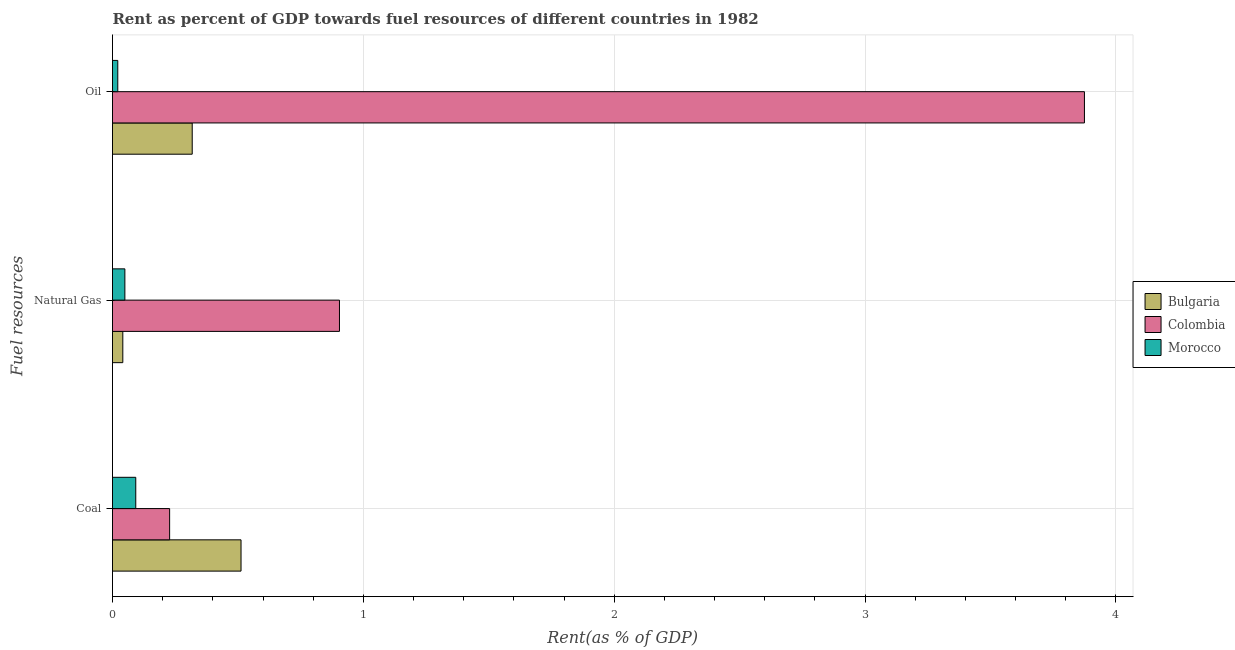Are the number of bars per tick equal to the number of legend labels?
Keep it short and to the point. Yes. How many bars are there on the 1st tick from the top?
Offer a very short reply. 3. How many bars are there on the 3rd tick from the bottom?
Your answer should be very brief. 3. What is the label of the 1st group of bars from the top?
Your answer should be compact. Oil. What is the rent towards natural gas in Bulgaria?
Keep it short and to the point. 0.04. Across all countries, what is the maximum rent towards natural gas?
Keep it short and to the point. 0.9. Across all countries, what is the minimum rent towards natural gas?
Offer a very short reply. 0.04. In which country was the rent towards oil minimum?
Keep it short and to the point. Morocco. What is the total rent towards oil in the graph?
Give a very brief answer. 4.21. What is the difference between the rent towards oil in Colombia and that in Morocco?
Your answer should be compact. 3.85. What is the difference between the rent towards natural gas in Morocco and the rent towards oil in Bulgaria?
Provide a short and direct response. -0.27. What is the average rent towards coal per country?
Give a very brief answer. 0.28. What is the difference between the rent towards coal and rent towards oil in Colombia?
Provide a succinct answer. -3.65. In how many countries, is the rent towards oil greater than 2.2 %?
Your answer should be very brief. 1. What is the ratio of the rent towards natural gas in Morocco to that in Colombia?
Make the answer very short. 0.05. Is the rent towards coal in Morocco less than that in Colombia?
Make the answer very short. Yes. What is the difference between the highest and the second highest rent towards coal?
Your response must be concise. 0.28. What is the difference between the highest and the lowest rent towards natural gas?
Your answer should be compact. 0.86. Is the sum of the rent towards natural gas in Colombia and Morocco greater than the maximum rent towards oil across all countries?
Give a very brief answer. No. How many bars are there?
Provide a succinct answer. 9. Are all the bars in the graph horizontal?
Make the answer very short. Yes. How many countries are there in the graph?
Provide a short and direct response. 3. What is the difference between two consecutive major ticks on the X-axis?
Offer a terse response. 1. Are the values on the major ticks of X-axis written in scientific E-notation?
Offer a very short reply. No. Does the graph contain grids?
Make the answer very short. Yes. Where does the legend appear in the graph?
Your response must be concise. Center right. How many legend labels are there?
Provide a succinct answer. 3. What is the title of the graph?
Your answer should be very brief. Rent as percent of GDP towards fuel resources of different countries in 1982. What is the label or title of the X-axis?
Your answer should be very brief. Rent(as % of GDP). What is the label or title of the Y-axis?
Your response must be concise. Fuel resources. What is the Rent(as % of GDP) of Bulgaria in Coal?
Give a very brief answer. 0.51. What is the Rent(as % of GDP) in Colombia in Coal?
Provide a short and direct response. 0.23. What is the Rent(as % of GDP) of Morocco in Coal?
Ensure brevity in your answer.  0.09. What is the Rent(as % of GDP) of Bulgaria in Natural Gas?
Offer a very short reply. 0.04. What is the Rent(as % of GDP) of Colombia in Natural Gas?
Offer a terse response. 0.9. What is the Rent(as % of GDP) in Morocco in Natural Gas?
Your response must be concise. 0.05. What is the Rent(as % of GDP) of Bulgaria in Oil?
Your answer should be compact. 0.32. What is the Rent(as % of GDP) in Colombia in Oil?
Offer a very short reply. 3.87. What is the Rent(as % of GDP) of Morocco in Oil?
Give a very brief answer. 0.02. Across all Fuel resources, what is the maximum Rent(as % of GDP) of Bulgaria?
Your response must be concise. 0.51. Across all Fuel resources, what is the maximum Rent(as % of GDP) in Colombia?
Your answer should be compact. 3.87. Across all Fuel resources, what is the maximum Rent(as % of GDP) in Morocco?
Keep it short and to the point. 0.09. Across all Fuel resources, what is the minimum Rent(as % of GDP) in Bulgaria?
Your response must be concise. 0.04. Across all Fuel resources, what is the minimum Rent(as % of GDP) in Colombia?
Offer a terse response. 0.23. Across all Fuel resources, what is the minimum Rent(as % of GDP) of Morocco?
Your answer should be compact. 0.02. What is the total Rent(as % of GDP) of Bulgaria in the graph?
Your answer should be compact. 0.87. What is the total Rent(as % of GDP) in Colombia in the graph?
Your response must be concise. 5.01. What is the total Rent(as % of GDP) of Morocco in the graph?
Your answer should be very brief. 0.16. What is the difference between the Rent(as % of GDP) in Bulgaria in Coal and that in Natural Gas?
Make the answer very short. 0.47. What is the difference between the Rent(as % of GDP) in Colombia in Coal and that in Natural Gas?
Ensure brevity in your answer.  -0.68. What is the difference between the Rent(as % of GDP) of Morocco in Coal and that in Natural Gas?
Make the answer very short. 0.04. What is the difference between the Rent(as % of GDP) in Bulgaria in Coal and that in Oil?
Ensure brevity in your answer.  0.19. What is the difference between the Rent(as % of GDP) in Colombia in Coal and that in Oil?
Your response must be concise. -3.65. What is the difference between the Rent(as % of GDP) of Morocco in Coal and that in Oil?
Offer a very short reply. 0.07. What is the difference between the Rent(as % of GDP) in Bulgaria in Natural Gas and that in Oil?
Offer a very short reply. -0.28. What is the difference between the Rent(as % of GDP) of Colombia in Natural Gas and that in Oil?
Offer a very short reply. -2.97. What is the difference between the Rent(as % of GDP) of Morocco in Natural Gas and that in Oil?
Offer a terse response. 0.03. What is the difference between the Rent(as % of GDP) of Bulgaria in Coal and the Rent(as % of GDP) of Colombia in Natural Gas?
Your answer should be compact. -0.39. What is the difference between the Rent(as % of GDP) in Bulgaria in Coal and the Rent(as % of GDP) in Morocco in Natural Gas?
Your answer should be very brief. 0.46. What is the difference between the Rent(as % of GDP) of Colombia in Coal and the Rent(as % of GDP) of Morocco in Natural Gas?
Offer a terse response. 0.18. What is the difference between the Rent(as % of GDP) in Bulgaria in Coal and the Rent(as % of GDP) in Colombia in Oil?
Keep it short and to the point. -3.36. What is the difference between the Rent(as % of GDP) in Bulgaria in Coal and the Rent(as % of GDP) in Morocco in Oil?
Give a very brief answer. 0.49. What is the difference between the Rent(as % of GDP) in Colombia in Coal and the Rent(as % of GDP) in Morocco in Oil?
Your response must be concise. 0.21. What is the difference between the Rent(as % of GDP) in Bulgaria in Natural Gas and the Rent(as % of GDP) in Colombia in Oil?
Your answer should be compact. -3.83. What is the difference between the Rent(as % of GDP) of Colombia in Natural Gas and the Rent(as % of GDP) of Morocco in Oil?
Offer a very short reply. 0.88. What is the average Rent(as % of GDP) in Bulgaria per Fuel resources?
Give a very brief answer. 0.29. What is the average Rent(as % of GDP) of Colombia per Fuel resources?
Provide a short and direct response. 1.67. What is the average Rent(as % of GDP) in Morocco per Fuel resources?
Make the answer very short. 0.05. What is the difference between the Rent(as % of GDP) in Bulgaria and Rent(as % of GDP) in Colombia in Coal?
Keep it short and to the point. 0.28. What is the difference between the Rent(as % of GDP) in Bulgaria and Rent(as % of GDP) in Morocco in Coal?
Provide a short and direct response. 0.42. What is the difference between the Rent(as % of GDP) in Colombia and Rent(as % of GDP) in Morocco in Coal?
Provide a succinct answer. 0.14. What is the difference between the Rent(as % of GDP) of Bulgaria and Rent(as % of GDP) of Colombia in Natural Gas?
Your response must be concise. -0.86. What is the difference between the Rent(as % of GDP) in Bulgaria and Rent(as % of GDP) in Morocco in Natural Gas?
Ensure brevity in your answer.  -0.01. What is the difference between the Rent(as % of GDP) of Colombia and Rent(as % of GDP) of Morocco in Natural Gas?
Provide a succinct answer. 0.86. What is the difference between the Rent(as % of GDP) in Bulgaria and Rent(as % of GDP) in Colombia in Oil?
Ensure brevity in your answer.  -3.56. What is the difference between the Rent(as % of GDP) of Bulgaria and Rent(as % of GDP) of Morocco in Oil?
Offer a terse response. 0.3. What is the difference between the Rent(as % of GDP) in Colombia and Rent(as % of GDP) in Morocco in Oil?
Your answer should be compact. 3.85. What is the ratio of the Rent(as % of GDP) of Bulgaria in Coal to that in Natural Gas?
Make the answer very short. 12.48. What is the ratio of the Rent(as % of GDP) of Colombia in Coal to that in Natural Gas?
Provide a succinct answer. 0.25. What is the ratio of the Rent(as % of GDP) in Morocco in Coal to that in Natural Gas?
Your answer should be compact. 1.88. What is the ratio of the Rent(as % of GDP) of Bulgaria in Coal to that in Oil?
Keep it short and to the point. 1.61. What is the ratio of the Rent(as % of GDP) in Colombia in Coal to that in Oil?
Provide a short and direct response. 0.06. What is the ratio of the Rent(as % of GDP) in Morocco in Coal to that in Oil?
Provide a succinct answer. 4.41. What is the ratio of the Rent(as % of GDP) of Bulgaria in Natural Gas to that in Oil?
Your response must be concise. 0.13. What is the ratio of the Rent(as % of GDP) in Colombia in Natural Gas to that in Oil?
Make the answer very short. 0.23. What is the ratio of the Rent(as % of GDP) of Morocco in Natural Gas to that in Oil?
Ensure brevity in your answer.  2.34. What is the difference between the highest and the second highest Rent(as % of GDP) in Bulgaria?
Provide a succinct answer. 0.19. What is the difference between the highest and the second highest Rent(as % of GDP) of Colombia?
Your answer should be very brief. 2.97. What is the difference between the highest and the second highest Rent(as % of GDP) in Morocco?
Your answer should be very brief. 0.04. What is the difference between the highest and the lowest Rent(as % of GDP) in Bulgaria?
Your answer should be very brief. 0.47. What is the difference between the highest and the lowest Rent(as % of GDP) in Colombia?
Keep it short and to the point. 3.65. What is the difference between the highest and the lowest Rent(as % of GDP) in Morocco?
Your answer should be very brief. 0.07. 